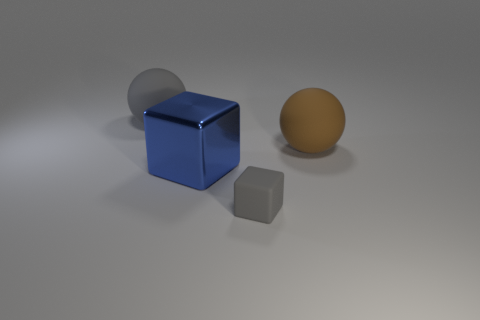There is a ball that is the same color as the tiny rubber thing; what is its size?
Ensure brevity in your answer.  Large. There is a tiny block; is its color the same as the rubber thing that is behind the big brown matte ball?
Keep it short and to the point. Yes. Is the big gray ball made of the same material as the block that is in front of the large blue cube?
Give a very brief answer. Yes. Are there fewer small things in front of the tiny block than blue shiny things in front of the blue cube?
Provide a succinct answer. No. How many objects have the same material as the large brown ball?
Give a very brief answer. 2. There is a rubber sphere behind the large sphere on the right side of the tiny rubber object; are there any large blue blocks on the right side of it?
Keep it short and to the point. Yes. How many balls are either big metal things or rubber things?
Give a very brief answer. 2. There is a large gray rubber object; is its shape the same as the large rubber thing in front of the large gray matte object?
Provide a succinct answer. Yes. Is the number of brown matte spheres to the left of the small gray rubber thing less than the number of small gray metallic balls?
Your answer should be very brief. No. There is a big blue shiny thing; are there any big blue objects in front of it?
Make the answer very short. No. 